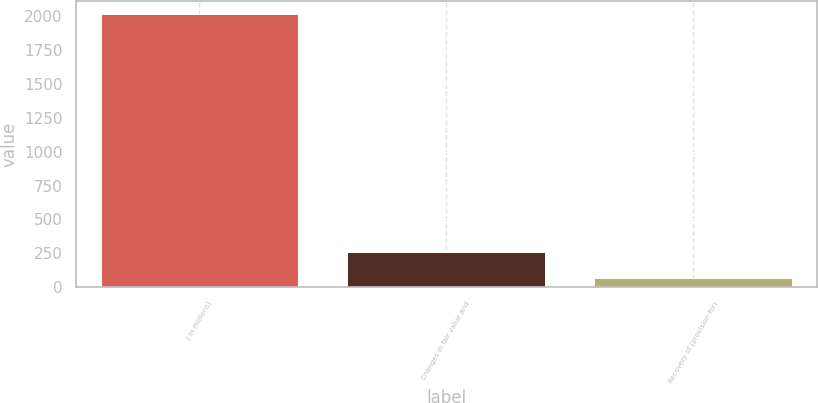Convert chart to OTSL. <chart><loc_0><loc_0><loc_500><loc_500><bar_chart><fcel>( in millions)<fcel>Changes in fair value and<fcel>Recovery of (provision for)<nl><fcel>2014<fcel>259.9<fcel>65<nl></chart> 